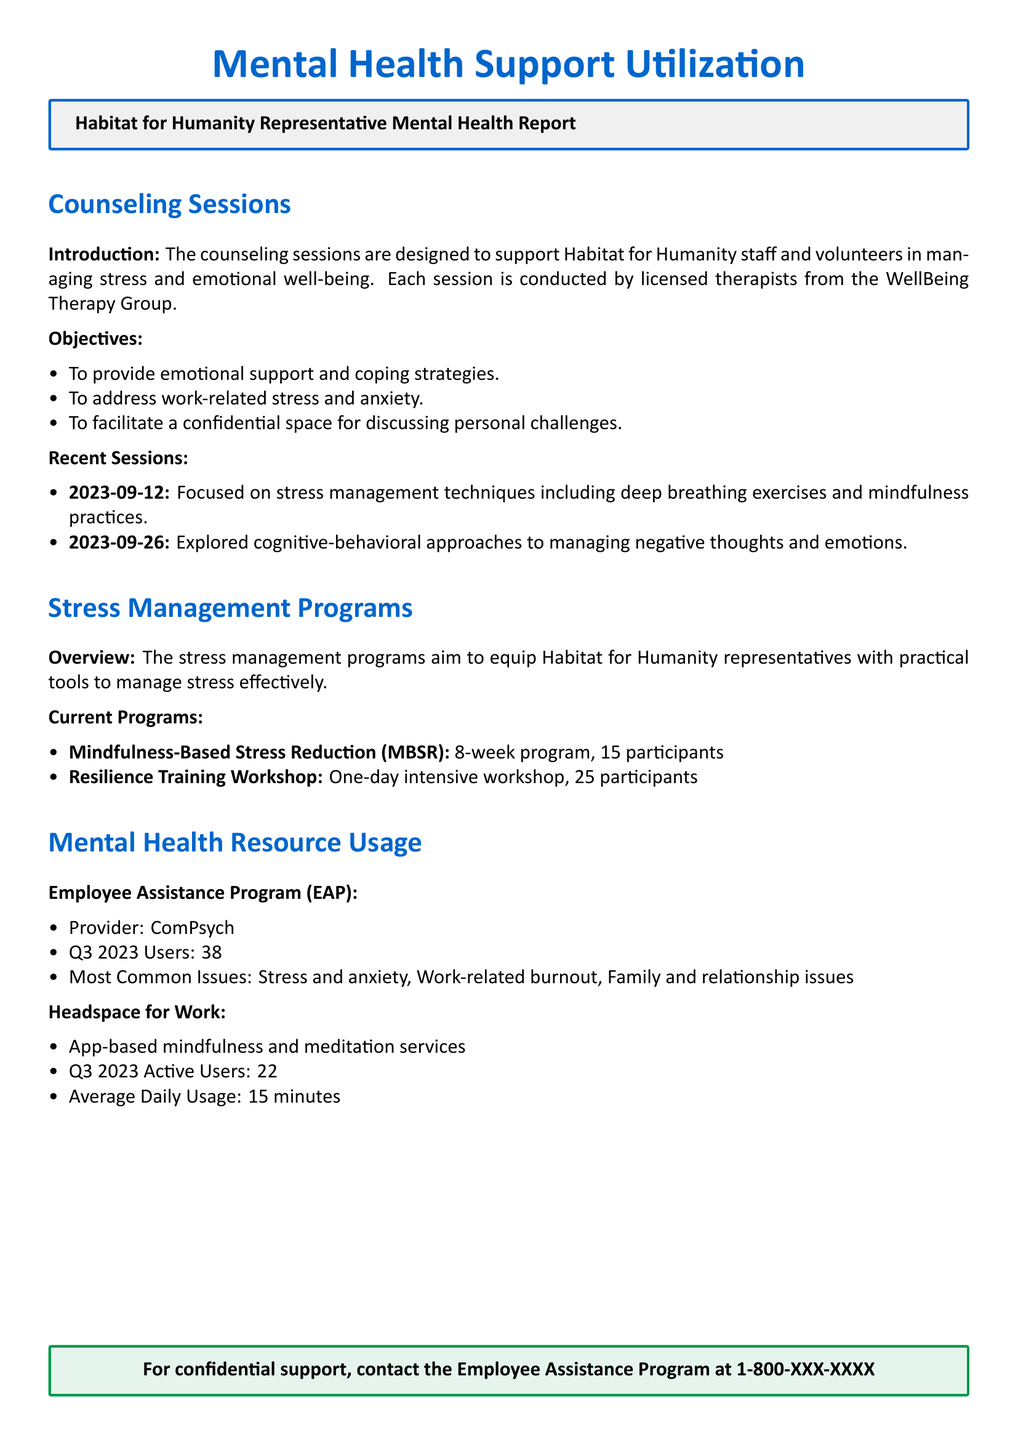What was the date of the first counseling session? The first counseling session date is provided under Recent Sessions, which is 2023-09-12.
Answer: 2023-09-12 How many participants are in the Mindfulness-Based Stress Reduction program? The number of participants for MBSR is listed under Current Programs, which states 15 participants.
Answer: 15 participants What is the most common issue reported in the Employee Assistance Program? The document states that the most common issues are stress and anxiety in the Employee Assistance Program section.
Answer: Stress and anxiety How many users utilized the Employee Assistance Program in Q3 2023? The document indicates that there were 38 users of the Employee Assistance Program in Q3 2023.
Answer: 38 What stress management technique was focused on in the session on 2023-09-12? The technique discussed in the session on this date is stress management techniques including deep breathing exercises and mindfulness practices.
Answer: Deep breathing exercises and mindfulness practices What is the average daily usage time for Headspace for Work users? The document says that the average daily usage for Headspace for Work is 15 minutes.
Answer: 15 minutes What was the focus of the counseling session on 2023-09-26? The session on this date focused on cognitive-behavioral approaches to managing negative thoughts and emotions.
Answer: Cognitive-behavioral approaches How long is the Mindfulness-Based Stress Reduction program? The duration of the MBSR program is mentioned as an 8-week program.
Answer: 8-week program 